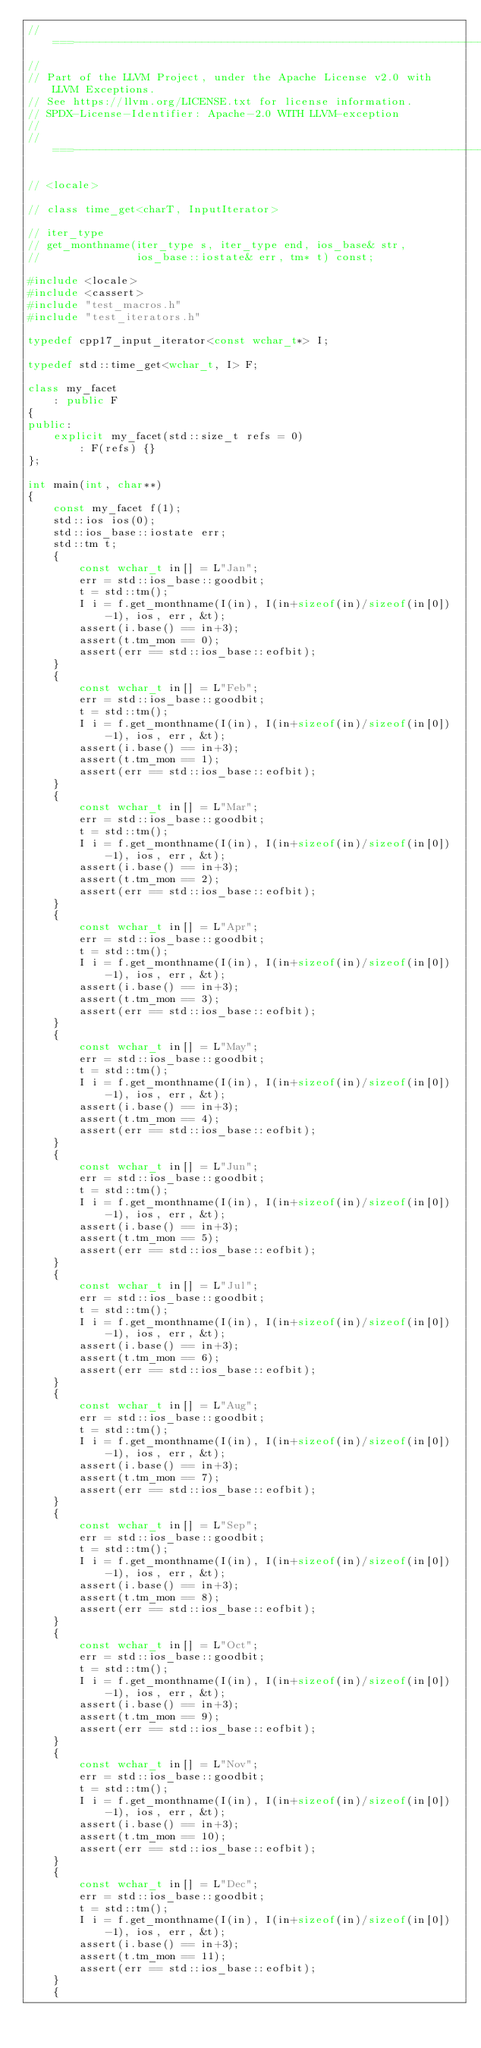Convert code to text. <code><loc_0><loc_0><loc_500><loc_500><_C++_>//===----------------------------------------------------------------------===//
//
// Part of the LLVM Project, under the Apache License v2.0 with LLVM Exceptions.
// See https://llvm.org/LICENSE.txt for license information.
// SPDX-License-Identifier: Apache-2.0 WITH LLVM-exception
//
//===----------------------------------------------------------------------===//

// <locale>

// class time_get<charT, InputIterator>

// iter_type
// get_monthname(iter_type s, iter_type end, ios_base& str,
//               ios_base::iostate& err, tm* t) const;

#include <locale>
#include <cassert>
#include "test_macros.h"
#include "test_iterators.h"

typedef cpp17_input_iterator<const wchar_t*> I;

typedef std::time_get<wchar_t, I> F;

class my_facet
    : public F
{
public:
    explicit my_facet(std::size_t refs = 0)
        : F(refs) {}
};

int main(int, char**)
{
    const my_facet f(1);
    std::ios ios(0);
    std::ios_base::iostate err;
    std::tm t;
    {
        const wchar_t in[] = L"Jan";
        err = std::ios_base::goodbit;
        t = std::tm();
        I i = f.get_monthname(I(in), I(in+sizeof(in)/sizeof(in[0])-1), ios, err, &t);
        assert(i.base() == in+3);
        assert(t.tm_mon == 0);
        assert(err == std::ios_base::eofbit);
    }
    {
        const wchar_t in[] = L"Feb";
        err = std::ios_base::goodbit;
        t = std::tm();
        I i = f.get_monthname(I(in), I(in+sizeof(in)/sizeof(in[0])-1), ios, err, &t);
        assert(i.base() == in+3);
        assert(t.tm_mon == 1);
        assert(err == std::ios_base::eofbit);
    }
    {
        const wchar_t in[] = L"Mar";
        err = std::ios_base::goodbit;
        t = std::tm();
        I i = f.get_monthname(I(in), I(in+sizeof(in)/sizeof(in[0])-1), ios, err, &t);
        assert(i.base() == in+3);
        assert(t.tm_mon == 2);
        assert(err == std::ios_base::eofbit);
    }
    {
        const wchar_t in[] = L"Apr";
        err = std::ios_base::goodbit;
        t = std::tm();
        I i = f.get_monthname(I(in), I(in+sizeof(in)/sizeof(in[0])-1), ios, err, &t);
        assert(i.base() == in+3);
        assert(t.tm_mon == 3);
        assert(err == std::ios_base::eofbit);
    }
    {
        const wchar_t in[] = L"May";
        err = std::ios_base::goodbit;
        t = std::tm();
        I i = f.get_monthname(I(in), I(in+sizeof(in)/sizeof(in[0])-1), ios, err, &t);
        assert(i.base() == in+3);
        assert(t.tm_mon == 4);
        assert(err == std::ios_base::eofbit);
    }
    {
        const wchar_t in[] = L"Jun";
        err = std::ios_base::goodbit;
        t = std::tm();
        I i = f.get_monthname(I(in), I(in+sizeof(in)/sizeof(in[0])-1), ios, err, &t);
        assert(i.base() == in+3);
        assert(t.tm_mon == 5);
        assert(err == std::ios_base::eofbit);
    }
    {
        const wchar_t in[] = L"Jul";
        err = std::ios_base::goodbit;
        t = std::tm();
        I i = f.get_monthname(I(in), I(in+sizeof(in)/sizeof(in[0])-1), ios, err, &t);
        assert(i.base() == in+3);
        assert(t.tm_mon == 6);
        assert(err == std::ios_base::eofbit);
    }
    {
        const wchar_t in[] = L"Aug";
        err = std::ios_base::goodbit;
        t = std::tm();
        I i = f.get_monthname(I(in), I(in+sizeof(in)/sizeof(in[0])-1), ios, err, &t);
        assert(i.base() == in+3);
        assert(t.tm_mon == 7);
        assert(err == std::ios_base::eofbit);
    }
    {
        const wchar_t in[] = L"Sep";
        err = std::ios_base::goodbit;
        t = std::tm();
        I i = f.get_monthname(I(in), I(in+sizeof(in)/sizeof(in[0])-1), ios, err, &t);
        assert(i.base() == in+3);
        assert(t.tm_mon == 8);
        assert(err == std::ios_base::eofbit);
    }
    {
        const wchar_t in[] = L"Oct";
        err = std::ios_base::goodbit;
        t = std::tm();
        I i = f.get_monthname(I(in), I(in+sizeof(in)/sizeof(in[0])-1), ios, err, &t);
        assert(i.base() == in+3);
        assert(t.tm_mon == 9);
        assert(err == std::ios_base::eofbit);
    }
    {
        const wchar_t in[] = L"Nov";
        err = std::ios_base::goodbit;
        t = std::tm();
        I i = f.get_monthname(I(in), I(in+sizeof(in)/sizeof(in[0])-1), ios, err, &t);
        assert(i.base() == in+3);
        assert(t.tm_mon == 10);
        assert(err == std::ios_base::eofbit);
    }
    {
        const wchar_t in[] = L"Dec";
        err = std::ios_base::goodbit;
        t = std::tm();
        I i = f.get_monthname(I(in), I(in+sizeof(in)/sizeof(in[0])-1), ios, err, &t);
        assert(i.base() == in+3);
        assert(t.tm_mon == 11);
        assert(err == std::ios_base::eofbit);
    }
    {</code> 